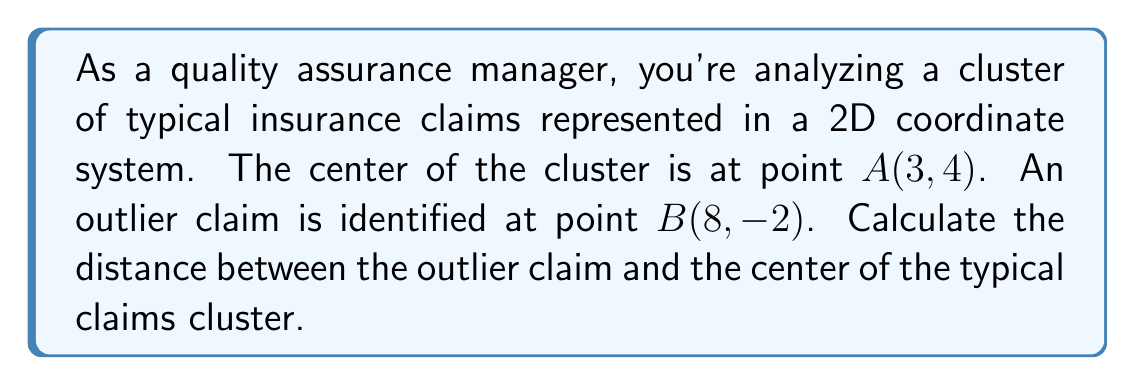What is the answer to this math problem? To find the distance between two points in a 2D coordinate system, we use the distance formula derived from the Pythagorean theorem:

$$d = \sqrt{(x_2 - x_1)^2 + (y_2 - y_1)^2}$$

Where $(x_1, y_1)$ are the coordinates of the first point and $(x_2, y_2)$ are the coordinates of the second point.

Given:
- Center of the cluster: $A(3, 4)$
- Outlier claim: $B(8, -2)$

Let's plug these values into the formula:

$$\begin{align}
d &= \sqrt{(x_2 - x_1)^2 + (y_2 - y_1)^2} \\
&= \sqrt{(8 - 3)^2 + (-2 - 4)^2} \\
&= \sqrt{5^2 + (-6)^2} \\
&= \sqrt{25 + 36} \\
&= \sqrt{61} \\
&\approx 7.81
\end{align}$$

The exact distance is $\sqrt{61}$ units, which is approximately 7.81 units when rounded to two decimal places.
Answer: $\sqrt{61}$ units 